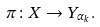<formula> <loc_0><loc_0><loc_500><loc_500>\pi \colon X \rightarrow Y _ { \alpha _ { k } } .</formula> 